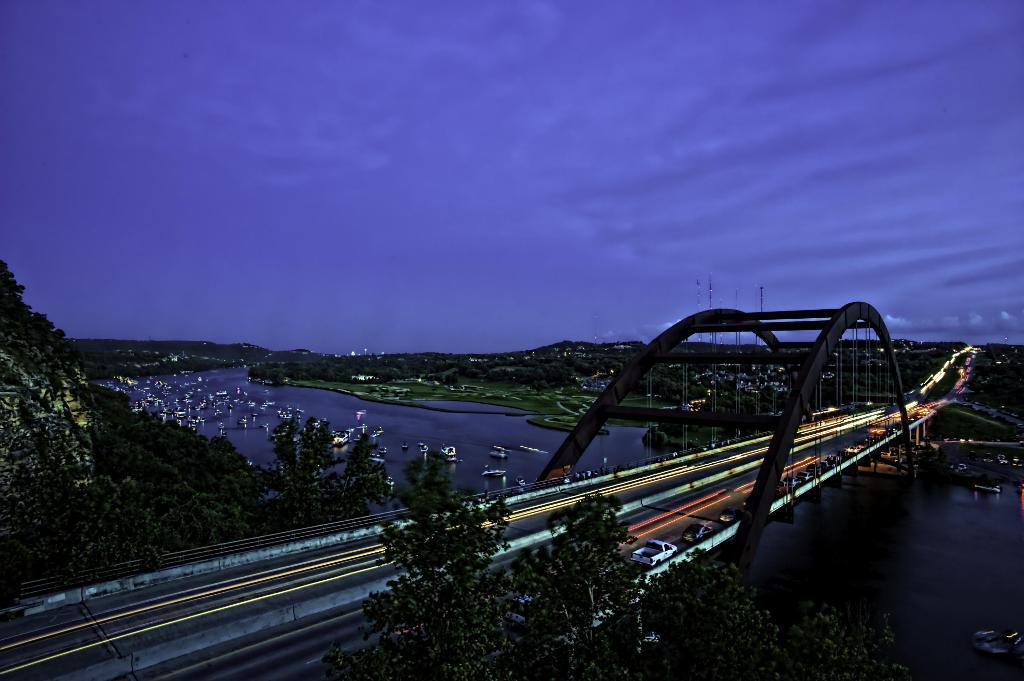What structure is present in the image? There is a bridge in the image. What feature of the bridge is mentioned in the facts? The bridge has lights. What is on the bridge? There are vehicles on the bridge. What else can be seen in the water near the bridge? There are boats on the water. What can be seen in the background of the image? There are trees, poles, mountains, and the sky visible in the background of the image. What type of fiction is being read by the grass in the image? There is no grass present in the image, and therefore no one can be reading fiction. 